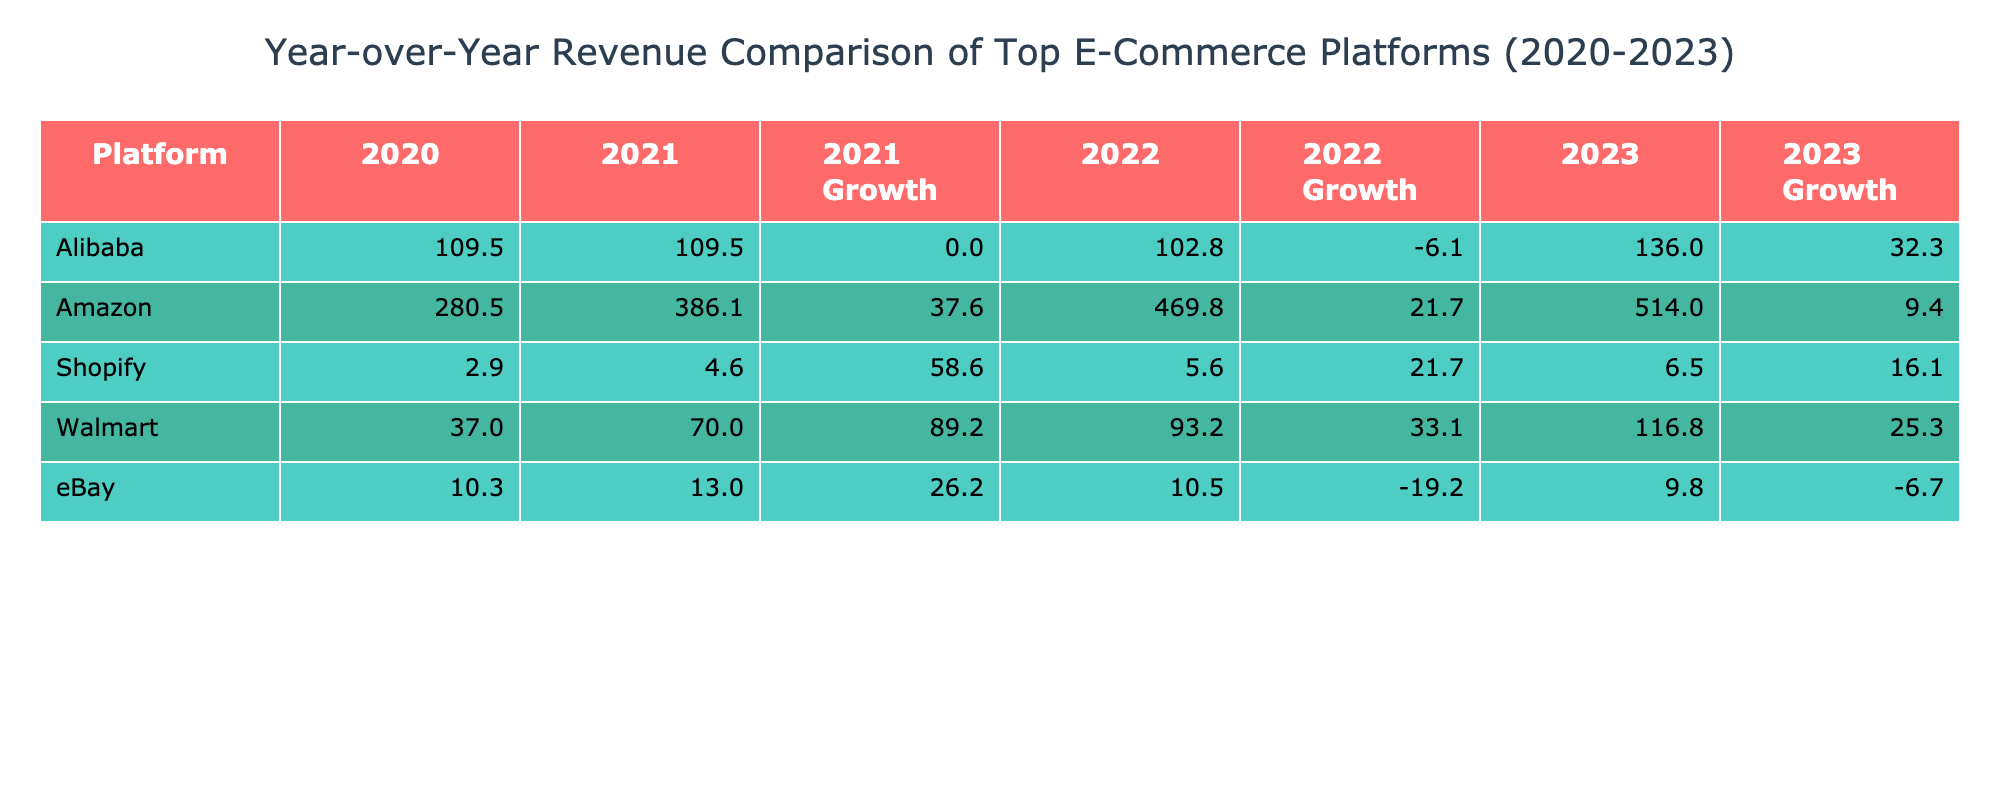What was the revenue of Amazon in 2022? In the table, we look under the year 2022 for Amazon's revenue value, which is directly stated as 469.8 billion USD.
Answer: 469.8 billion USD Which e-commerce platform had the highest revenue in 2021? By checking the revenue values for 2021 in the table, Amazon has the highest specified revenue of 386.1 billion USD compared to other platforms.
Answer: Amazon What is the year-over-year growth percentage of Walmart from 2021 to 2022? We first find Walmart's revenue for 2021, which is 70.0 billion USD, and for 2022, which is 93.2 billion USD. The growth is calculated as ((93.2 - 70.0) / 70.0) * 100 = 33.14%.
Answer: 33.14% Did eBay's revenue increase every year from 2020 to 2023? We look at the revenue for eBay across the years: 10.3 (2020), 13.0 (2021), 10.5 (2022), and 9.8 (2023). Notably, the revenues for 2022 and 2023 show a decrease from 2021 values. Hence, eBay's revenue did not increase every year.
Answer: No What is the total revenue earned by Alibaba from 2020 to 2023? To find the total revenue for Alibaba, we add their yearly revenues: 109.5 (2020) + 109.5 (2021) + 102.8 (2022) + 136.0 (2023) = 457.8 billion USD.
Answer: 457.8 billion USD Which platform had the most significant growth percentage in 2023 compared to 2022? We need to find the growth percentages for all platforms from 2022 to 2023. For Amazon, it’s ((514.0 - 469.8) / 469.8) * 100 = 9.43%; for Alibaba, it’s ((136.0 - 102.8) / 102.8) * 100 = 32.09%; and for Walmart, it’s ((116.8 - 93.2) / 93.2) * 100 = 25.43%. Alibaba had the highest growth percentage of 32.09%.
Answer: Alibaba What was the average revenue of Shopify from 2020 to 2023? The revenues for Shopify are 2.9 (2020), 4.6 (2021), 5.6 (2022), and 6.5 (2023). We sum these values (2.9 + 4.6 + 5.6 + 6.5 = 19.6) and divide by the number of years (4) to get an average of 19.6 / 4 = 4.9 billion USD.
Answer: 4.9 billion USD Which platform experienced a decrease in revenue from 2021 to 2023? By comparing the revenue values from 2021 to 2023 for each platform, we find that eBay's revenue decreased from 13.0 billion USD in 2021 to 9.8 billion USD in 2023, while the others either increased or remained constant.
Answer: eBay What is the percentage increase in revenue for Amazon from 2020 to 2023? To calculate Amazon’s percentage increase, we take the revenue for 2023 (514.0 billion USD) and the revenue for 2020 (280.5 billion USD). The calculation is ((514.0 - 280.5) / 280.5) * 100 = 83.23%.
Answer: 83.23% 